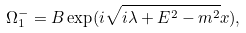<formula> <loc_0><loc_0><loc_500><loc_500>\Omega _ { 1 } ^ { - } = B \exp ( i \sqrt { i \lambda + E ^ { 2 } - m ^ { 2 } } x ) ,</formula> 